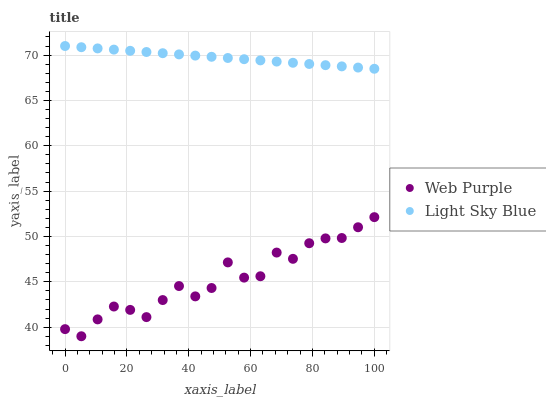Does Web Purple have the minimum area under the curve?
Answer yes or no. Yes. Does Light Sky Blue have the maximum area under the curve?
Answer yes or no. Yes. Does Light Sky Blue have the minimum area under the curve?
Answer yes or no. No. Is Light Sky Blue the smoothest?
Answer yes or no. Yes. Is Web Purple the roughest?
Answer yes or no. Yes. Is Light Sky Blue the roughest?
Answer yes or no. No. Does Web Purple have the lowest value?
Answer yes or no. Yes. Does Light Sky Blue have the lowest value?
Answer yes or no. No. Does Light Sky Blue have the highest value?
Answer yes or no. Yes. Is Web Purple less than Light Sky Blue?
Answer yes or no. Yes. Is Light Sky Blue greater than Web Purple?
Answer yes or no. Yes. Does Web Purple intersect Light Sky Blue?
Answer yes or no. No. 